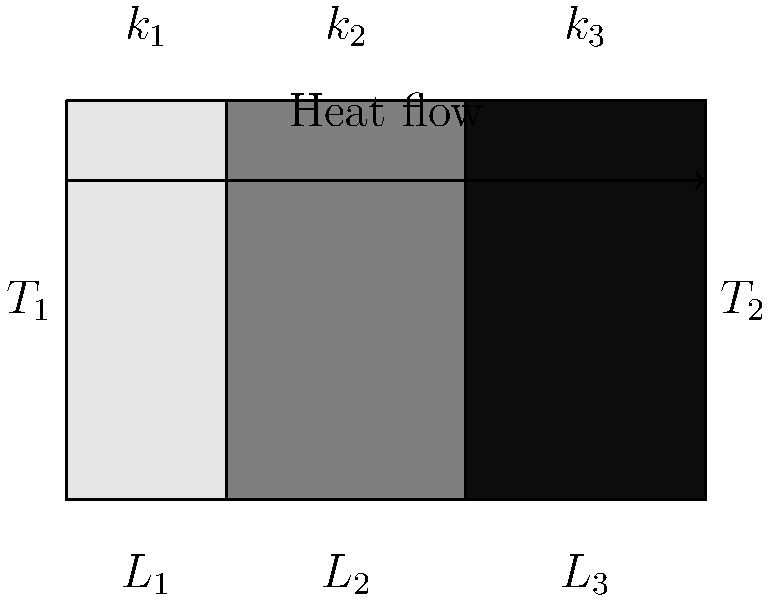Design a tactile model of a composite wall with three layers of different materials and thicknesses. The inner surface temperature is $T_1 = 80°C$, and the outer surface temperature is $T_2 = 20°C$. The thicknesses and thermal conductivities of the layers are:

Layer 1: $L_1 = 10$ cm, $k_1 = 0.8$ W/(m·K)
Layer 2: $L_2 = 15$ cm, $k_2 = 0.05$ W/(m·K)
Layer 3: $L_3 = 5$ cm, $k_3 = 0.3$ W/(m·K)

Calculate the rate of heat transfer through 1 m² of this composite wall. To solve this problem, we'll follow these steps:

1. Calculate the thermal resistance of each layer:
   $R_i = \frac{L_i}{k_i}$

   Layer 1: $R_1 = \frac{0.10}{0.8} = 0.125$ m²·K/W
   Layer 2: $R_2 = \frac{0.15}{0.05} = 3$ m²·K/W
   Layer 3: $R_3 = \frac{0.05}{0.3} = 0.167$ m²·K/W

2. Calculate the total thermal resistance:
   $R_{total} = R_1 + R_2 + R_3 = 0.125 + 3 + 0.167 = 3.292$ m²·K/W

3. Use Fourier's Law of heat conduction to calculate the heat transfer rate:
   $q = \frac{\Delta T}{R_{total}}$

   Where $\Delta T = T_1 - T_2 = 80°C - 20°C = 60°C$

   $q = \frac{60}{3.292} = 18.23$ W/m²

Therefore, the rate of heat transfer through 1 m² of this composite wall is approximately 18.23 W/m².
Answer: 18.23 W/m² 